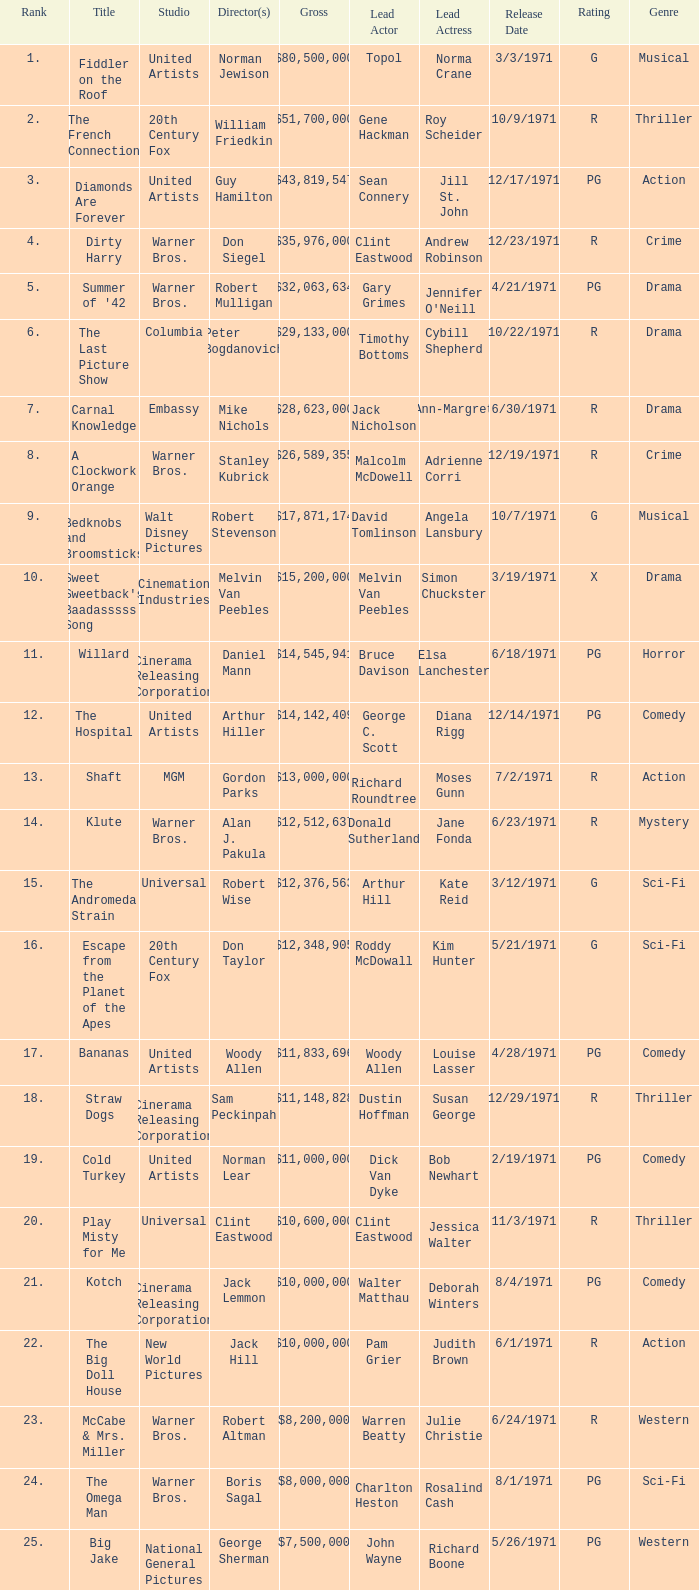What rank has a gross of $35,976,000? 4.0. 